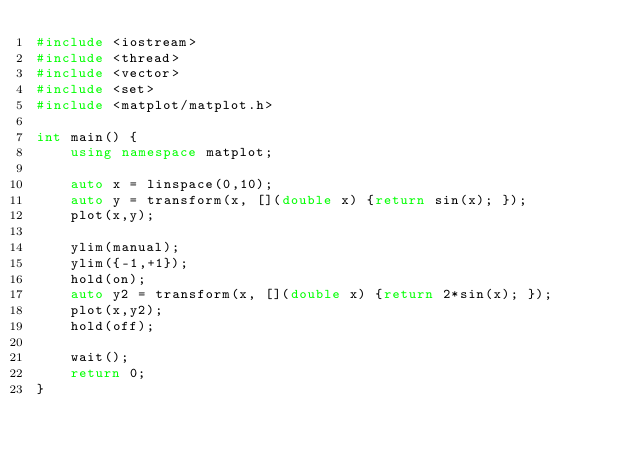<code> <loc_0><loc_0><loc_500><loc_500><_C++_>#include <iostream>
#include <thread>
#include <vector>
#include <set>
#include <matplot/matplot.h>

int main() {
    using namespace matplot;

    auto x = linspace(0,10);
    auto y = transform(x, [](double x) {return sin(x); });
    plot(x,y);

    ylim(manual);
    ylim({-1,+1});
    hold(on);
    auto y2 = transform(x, [](double x) {return 2*sin(x); });
    plot(x,y2);
    hold(off);

    wait();
    return 0;
}</code> 